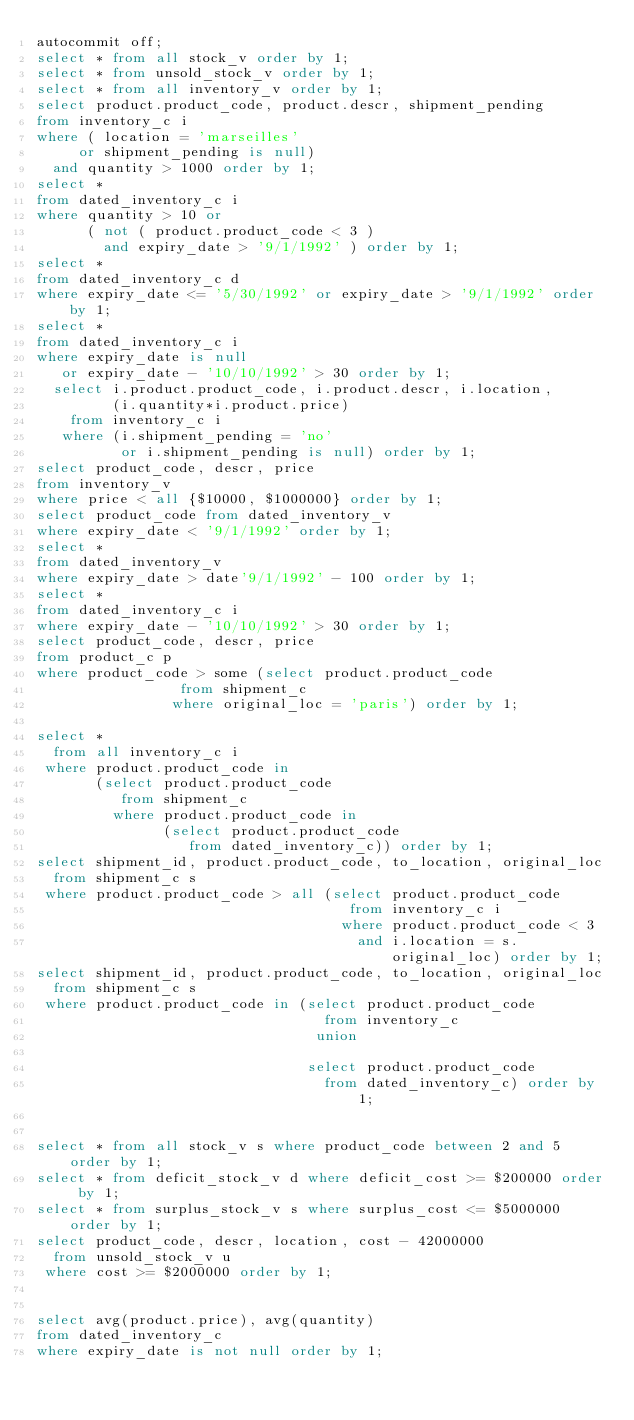<code> <loc_0><loc_0><loc_500><loc_500><_SQL_>autocommit off;
select * from all stock_v order by 1;
select * from unsold_stock_v order by 1;
select * from all inventory_v order by 1;
select product.product_code, product.descr, shipment_pending
from inventory_c i
where ( location = 'marseilles'
     or shipment_pending is null)
  and quantity > 1000 order by 1;
select *
from dated_inventory_c i
where quantity > 10 or
      ( not ( product.product_code < 3 )
        and expiry_date > '9/1/1992' ) order by 1;
select *
from dated_inventory_c d
where expiry_date <= '5/30/1992' or expiry_date > '9/1/1992' order by 1;
select *
from dated_inventory_c i
where expiry_date is null
   or expiry_date - '10/10/1992' > 30 order by 1;
  select i.product.product_code, i.product.descr, i.location,
         (i.quantity*i.product.price)
    from inventory_c i
   where (i.shipment_pending = 'no'
          or i.shipment_pending is null) order by 1;
select product_code, descr, price
from inventory_v
where price < all {$10000, $1000000} order by 1;
select product_code from dated_inventory_v
where expiry_date < '9/1/1992' order by 1;
select *
from dated_inventory_v
where expiry_date > date'9/1/1992' - 100 order by 1;
select *
from dated_inventory_c i
where expiry_date - '10/10/1992' > 30 order by 1;
select product_code, descr, price
from product_c p
where product_code > some (select product.product_code
			     from shipment_c
			    where original_loc = 'paris') order by 1;
				 	
select *
  from all inventory_c i
 where product.product_code in
       (select product.product_code
          from shipment_c
         where product.product_code in
               (select product.product_code
                  from dated_inventory_c)) order by 1;
select shipment_id, product.product_code, to_location, original_loc
  from shipment_c s
 where product.product_code > all (select product.product_code
                                     from inventory_c i
                                    where product.product_code < 3
                                      and i.location = s.original_loc) order by 1;
select shipment_id, product.product_code, to_location, original_loc
  from shipment_c s
 where product.product_code in (select product.product_code
                                  from inventory_c
                                 union
                                 
                                select product.product_code
                                  from dated_inventory_c) order by 1;
                                  
                                  
select * from all stock_v s where product_code between 2 and 5 order by 1;
select * from deficit_stock_v d where deficit_cost >= $200000 order by 1;
select * from surplus_stock_v s where surplus_cost <= $5000000 order by 1;
select product_code, descr, location, cost - 42000000
  from unsold_stock_v u
 where cost >= $2000000 order by 1;
 
 
select avg(product.price), avg(quantity)
from dated_inventory_c
where expiry_date is not null order by 1;</code> 